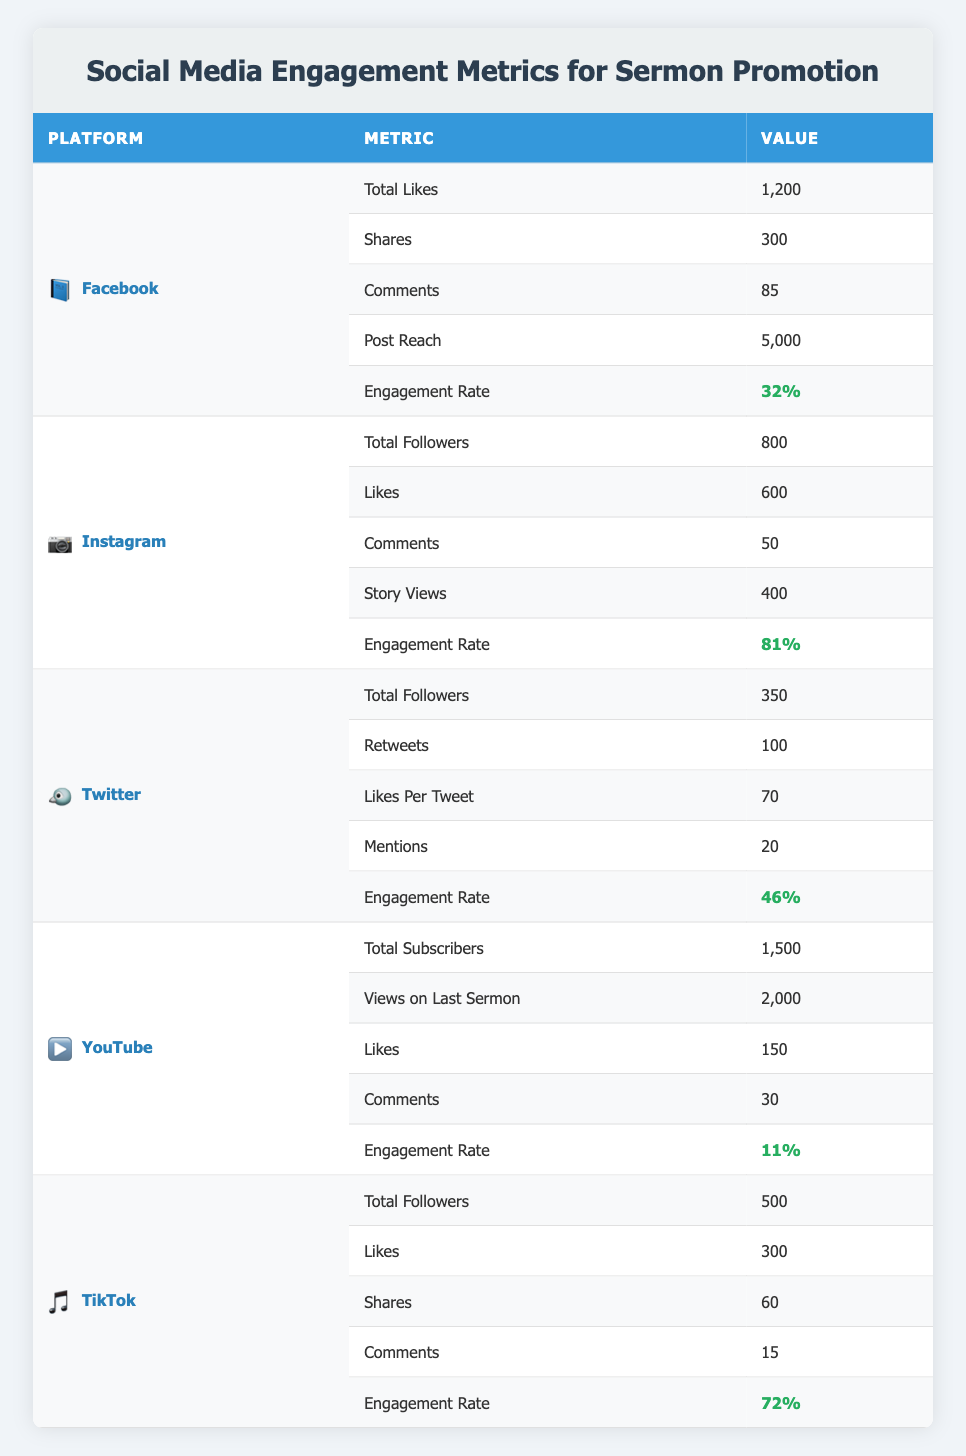What is the total number of likes on Facebook? The table shows that the total likes on Facebook are listed directly under the metric "Total Likes," which is 1,200.
Answer: 1,200 Which platform has the highest engagement rate? To determine this, we need to compare the engagement rates for each platform: Facebook 32%, Instagram 81%, Twitter 46%, YouTube 11%, and TikTok 72%. Instagram has the highest engagement rate of 81%.
Answer: Instagram 81% How many more shares does Facebook have than TikTok? The number of shares for Facebook is 300, and for TikTok it is 60. To find the difference, we subtract TikTok shares from Facebook shares: 300 - 60 = 240.
Answer: 240 Is the engagement rate on YouTube higher than that on TikTok? The engagement rate for YouTube is given as 11%, while TikTok's engagement rate is 72%. Since 11% is less than 72%, the statement is false.
Answer: No What is the total number of followers across all platforms? Total followers from each platform: Facebook not listed, Instagram 800, Twitter 350, YouTube not listed, TikTok 500. The total followers calculated will be 800 + 350 + 500. Since we do not have the Facebook and YouTube followers listed, we consider only the known numbers: 800 + 350 + 500 = 1650.
Answer: 1650 Which platform had the most comments? To find this, we evaluate the comments for each platform: Facebook 85, Instagram 50, Twitter 20, YouTube 30, and TikTok 15. The maximum is 85 comments on Facebook.
Answer: Facebook What is the average number of likes per platform? To compute the average, we sum the likes across all platforms that have the metric specified: Facebook 1200, Instagram 600, Twitter 70, YouTube 150, TikTok 300. Adding them gives: 1200 + 600 + 70 + 150 + 300 = 2320. There are 5 platforms, so the average is 2320 / 5 = 464.
Answer: 464 Does Instagram have more total likes than TikTok? From the table, Instagram has 600 likes, while TikTok has 300 likes. Since 600 is greater than 300, the statement is true.
Answer: Yes Which platform had the least number of views on the last sermon? Only YouTube has the metric "Views on Last Sermon", which is 2000 while other platforms do not provide this information. Hence, we only look at YouTube: It's 2000.
Answer: YouTube 2000 